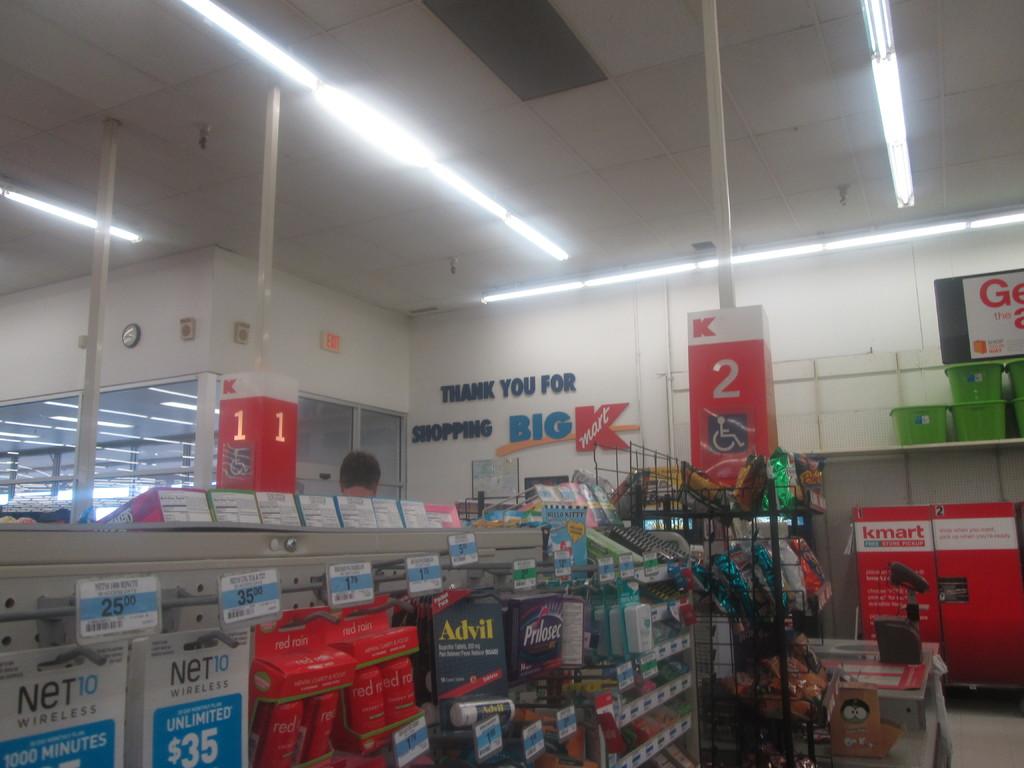How much does the 1000 minutes net10 cost?
Your answer should be very brief. 25.00. 